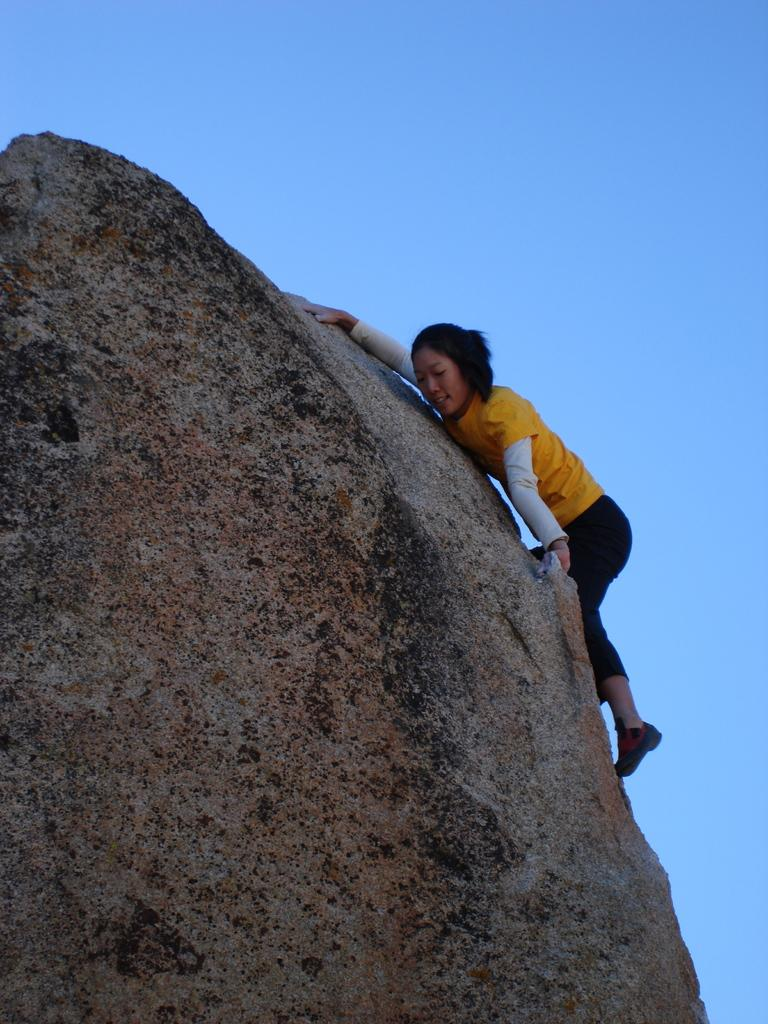Who is the main subject in the image? There is a girl in the image. What is the girl doing in the image? The girl is climbing a big rock. What is the girl's account number while she is climbing the rock in the image? There is no mention of an account number in the image, as it features a girl climbing a rock. 